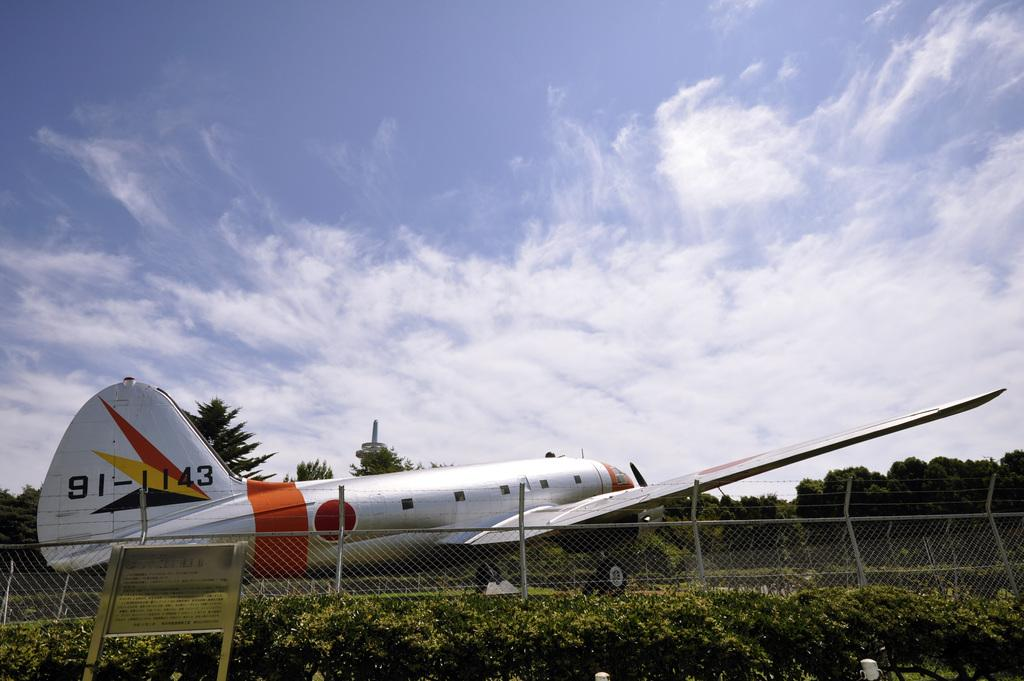What is the main subject of the image? There is an aeroplane in the image. What else can be seen in the image besides the aeroplane? There is a fence, plants, a board, trees, and the sky with clouds visible in the background of the image. Can you describe the fence in the image? The fence is a structure that separates or encloses areas in the image. What type of plants are present in the image? The plants in the image are not specified, but they are visible. How many mice can be seen running on the aeroplane in the image? There are no mice present in the image, so it is not possible to determine how many would be running on the aeroplane. 